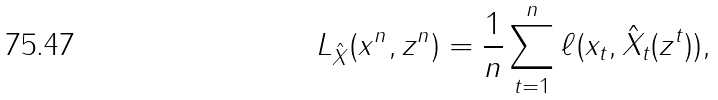Convert formula to latex. <formula><loc_0><loc_0><loc_500><loc_500>L _ { \hat { X } } ( x ^ { n } , z ^ { n } ) = \frac { 1 } { n } \sum _ { t = 1 } ^ { n } \ell ( x _ { t } , \hat { X } _ { t } ( z ^ { t } ) ) ,</formula> 